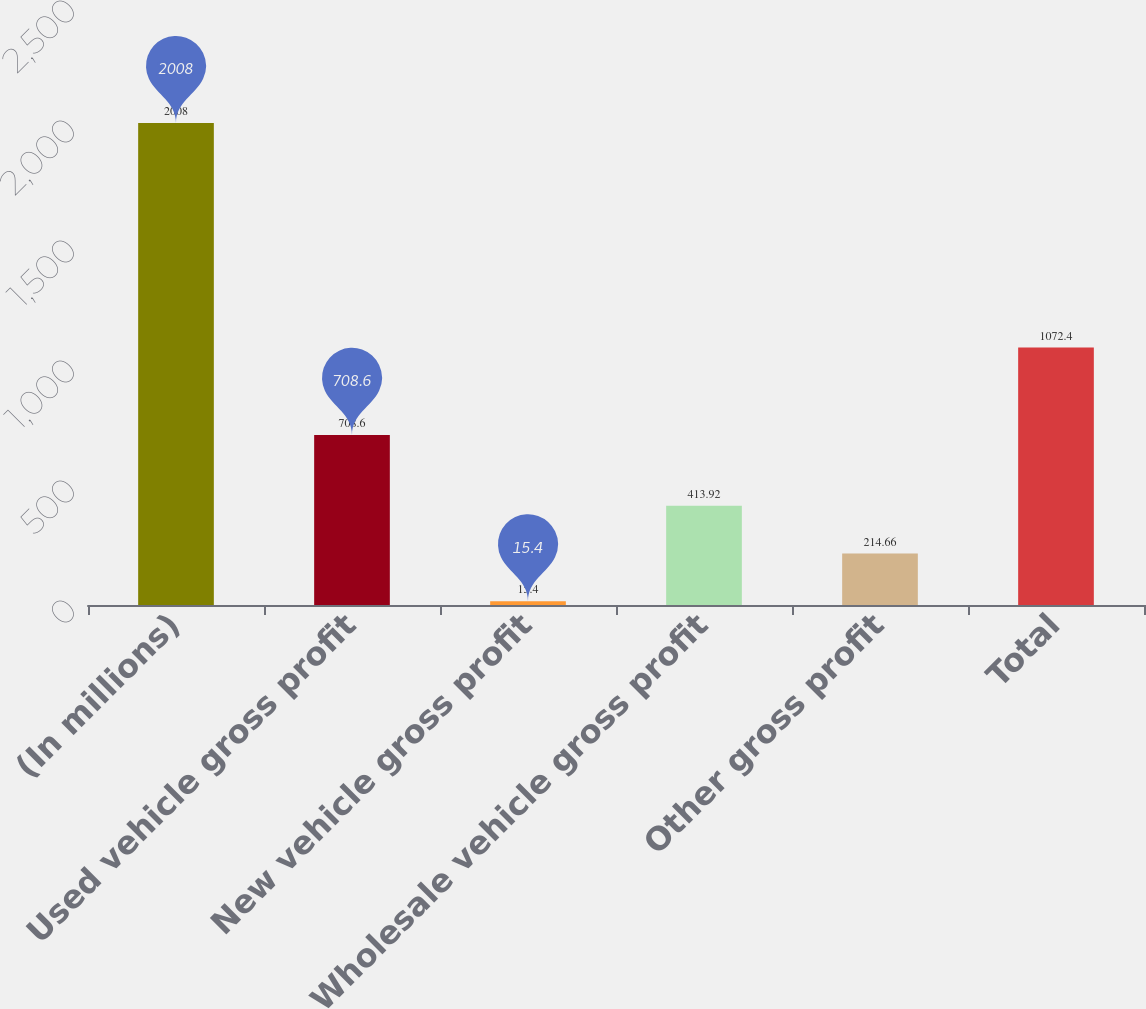Convert chart to OTSL. <chart><loc_0><loc_0><loc_500><loc_500><bar_chart><fcel>(In millions)<fcel>Used vehicle gross profit<fcel>New vehicle gross profit<fcel>Wholesale vehicle gross profit<fcel>Other gross profit<fcel>Total<nl><fcel>2008<fcel>708.6<fcel>15.4<fcel>413.92<fcel>214.66<fcel>1072.4<nl></chart> 